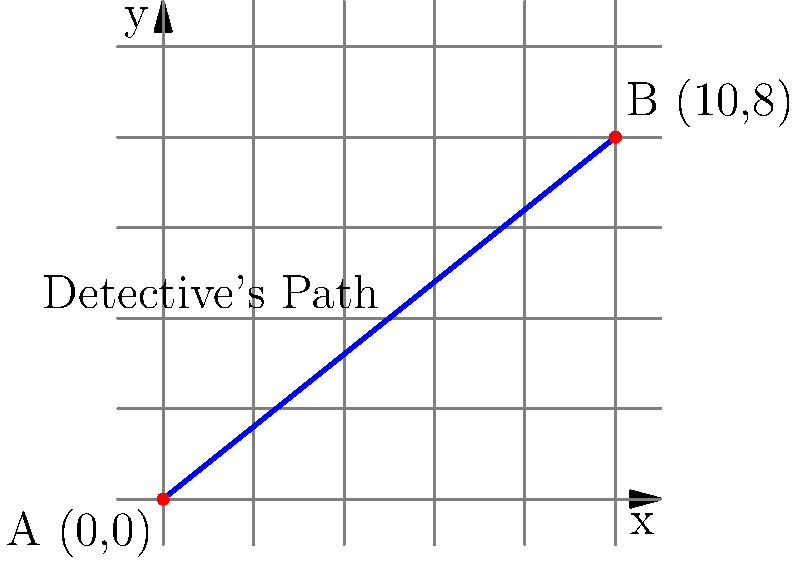In a thrilling crime scene investigation reminiscent of Satyajit Ray's "Feluda" series, a detective moves from point A (0,0) to point B (10,8) in a straight line, as shown in the diagram. What is the slope of the line representing the detective's path? Let's solve this step-by-step, using the slope formula:

1) The slope formula is:
   $m = \frac{y_2 - y_1}{x_2 - x_1}$

2) We have two points:
   Point A: $(x_1, y_1) = (0, 0)$
   Point B: $(x_2, y_2) = (10, 8)$

3) Let's substitute these values into the formula:
   $m = \frac{8 - 0}{10 - 0}$

4) Simplify:
   $m = \frac{8}{10}$

5) This fraction can be reduced:
   $m = \frac{4}{5}$

Therefore, the slope of the line representing the detective's path is $\frac{4}{5}$.
Answer: $\frac{4}{5}$ 